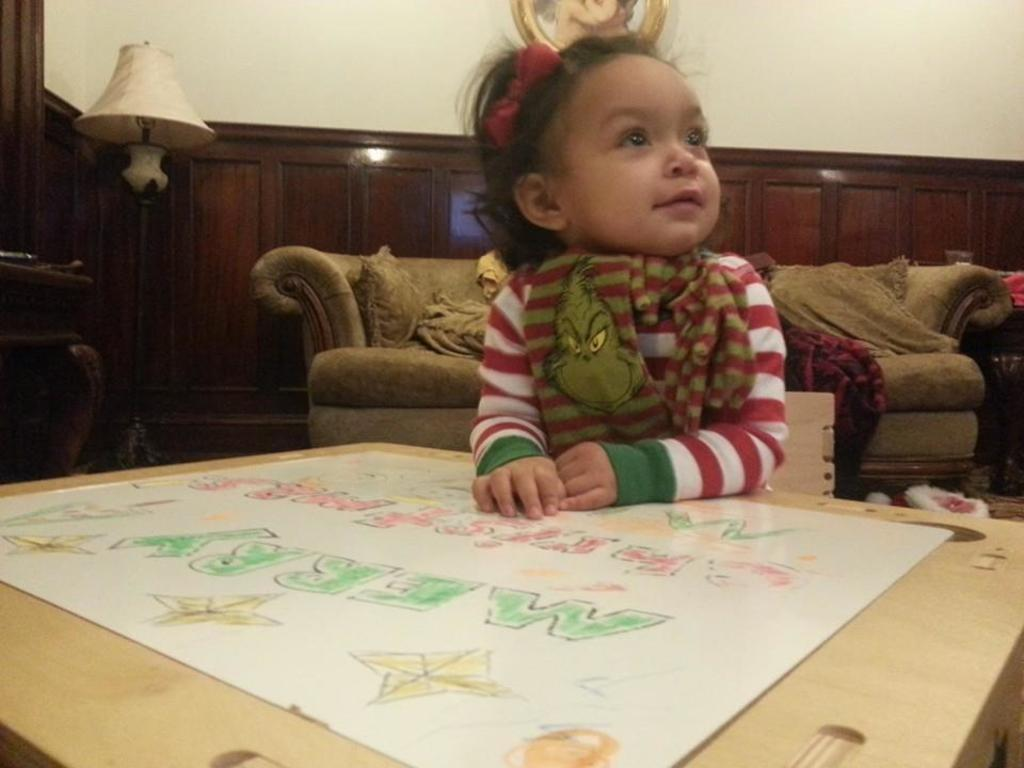Who is the main subject in the image? There is a girl in the image. What is the girl doing in the image? The girl is sitting. What object is in front of the girl? There is a cardboard box in front of the girl. What is on top of the cardboard box? There is a sheet of paper on the cardboard box. What type of grass is growing on the bed in the image? There is no grass or bed present in the image; it features a girl sitting with a cardboard box and a sheet of paper. 